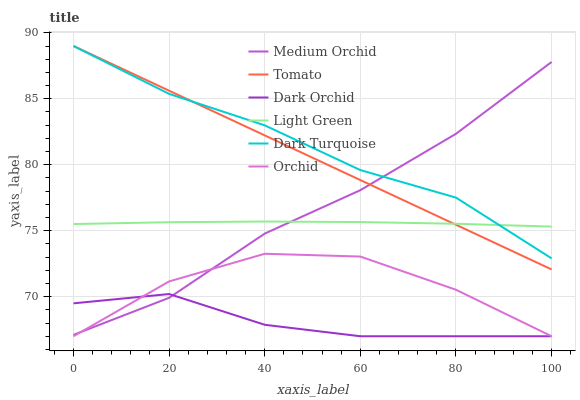Does Dark Orchid have the minimum area under the curve?
Answer yes or no. Yes. Does Dark Turquoise have the maximum area under the curve?
Answer yes or no. Yes. Does Medium Orchid have the minimum area under the curve?
Answer yes or no. No. Does Medium Orchid have the maximum area under the curve?
Answer yes or no. No. Is Tomato the smoothest?
Answer yes or no. Yes. Is Orchid the roughest?
Answer yes or no. Yes. Is Dark Turquoise the smoothest?
Answer yes or no. No. Is Dark Turquoise the roughest?
Answer yes or no. No. Does Dark Orchid have the lowest value?
Answer yes or no. Yes. Does Dark Turquoise have the lowest value?
Answer yes or no. No. Does Dark Turquoise have the highest value?
Answer yes or no. Yes. Does Medium Orchid have the highest value?
Answer yes or no. No. Is Dark Orchid less than Light Green?
Answer yes or no. Yes. Is Light Green greater than Dark Orchid?
Answer yes or no. Yes. Does Tomato intersect Dark Turquoise?
Answer yes or no. Yes. Is Tomato less than Dark Turquoise?
Answer yes or no. No. Is Tomato greater than Dark Turquoise?
Answer yes or no. No. Does Dark Orchid intersect Light Green?
Answer yes or no. No. 